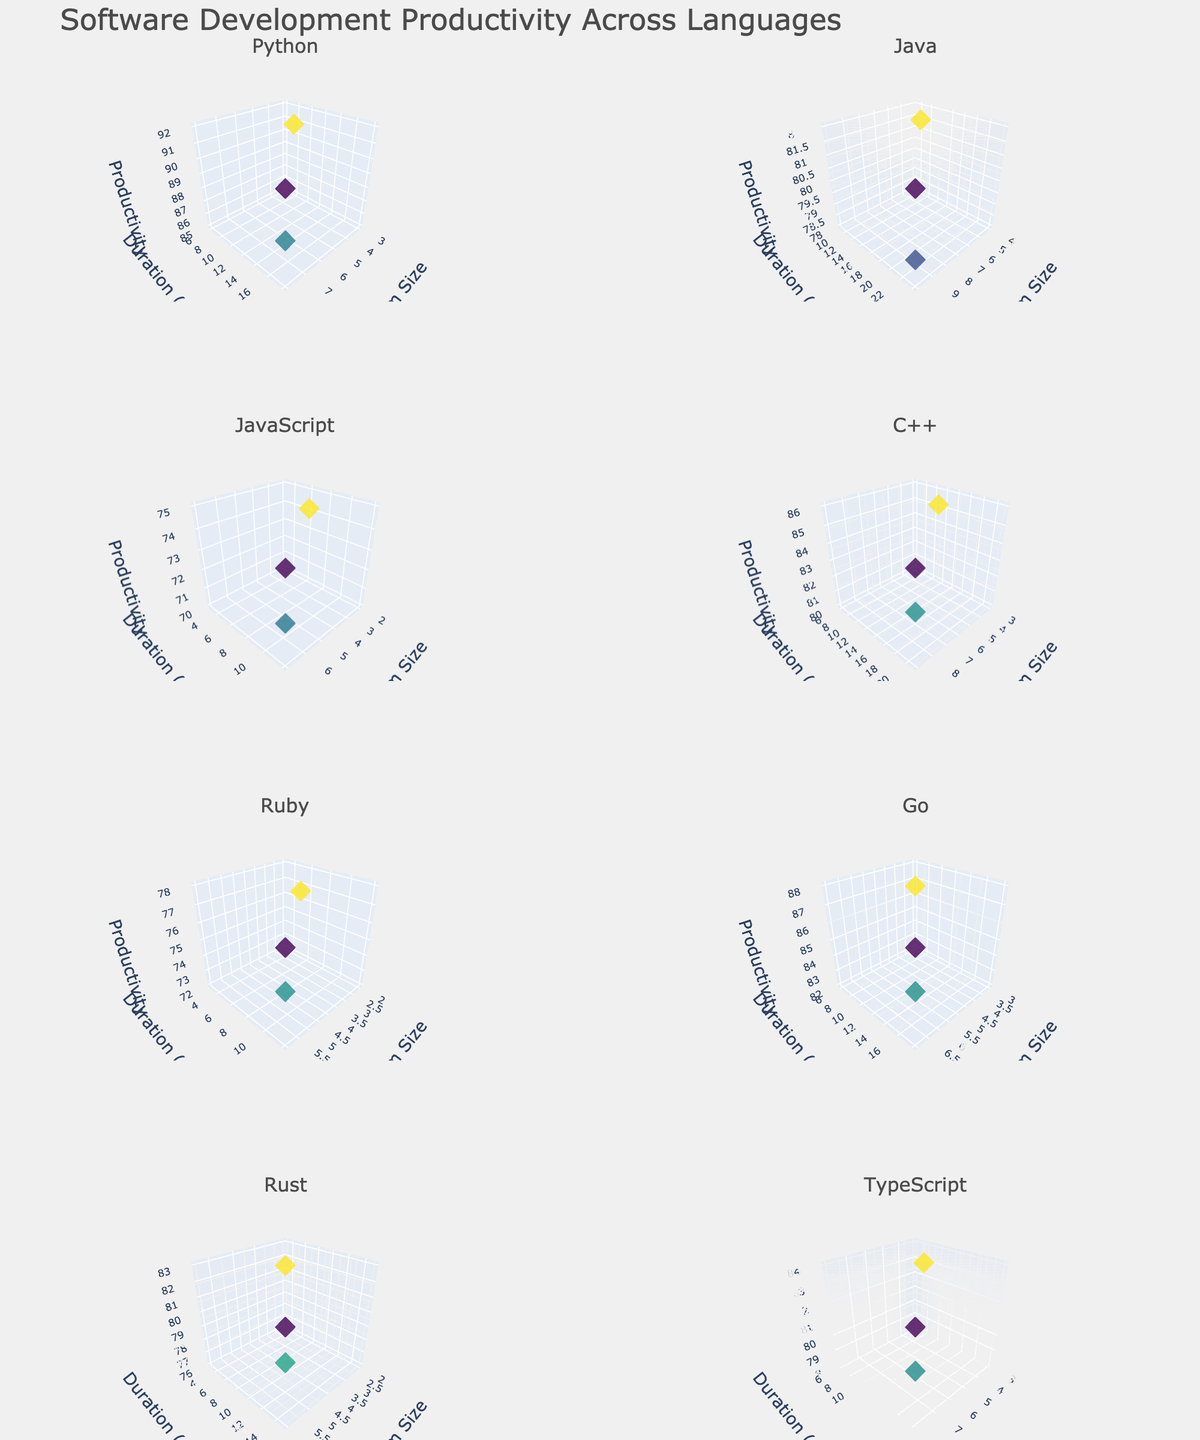How many subplots are there in the figure? There are 12 unique programming languages in the data. Each language is represented in a separate subplot, and the layout is arranged in 6 rows and 2 columns, resulting in a total of 12 subplots.
Answer: 12 Which language has the subplot with the highest maximum productivity? By examining the subplots, we see that the Python subplot has a data point with a productivity of 92, which is higher than the maximum values in the other subplots.
Answer: Python What is the average productivity across all programming languages for team size of 5? Looking at each subplot, we can extract the productivity values for team size 5: Python (92), Java (82), C++ (86), Go (88), TypeScript (84). The average is calculated as (92 + 82 + 86 + 88 + 84) / 5 = 86.4.
Answer: 86.4 How does productivity change with team size for Java? In the Java subplot, productivity values are 78 for team size 4, 82 for team size 6, and 79 for team size 10, suggesting a non-linear relationship with productivity peaking at a mid-sized team.
Answer: Peaks at mid-size Which language's productivity is least affected by project duration? By examining each subplot, we see the JavaScript subplot has smaller changes in productivity values (70 to 75), suggesting it is the least affected by project duration.
Answer: JavaScript Which programming language sees the highest productivity for short-duration (3 months) projects? For short-duration projects (3 months), Ruby has a productivity of 72, Rust has 76, JavaScript has 70. Rust has the highest productivity for short-duration projects.
Answer: Rust Among the programming languages, which one shows the biggest drop in productivity as team size increases? By examining the slope of the productivity trend with increasing team size, Java shows a noticeable drop from 82 at team size 6 to 79 at team size 10.
Answer: Java Do larger teams always lead to higher productivity in software development? Observing the subplots, we see that larger team sizes do not always lead to higher productivity. For instance, productivity decreases in cases like Java and C++.
Answer: No What is the relationship between team size and productivity for Go language projects? In the Go subplot, productivity values are 82 for team size 3, 88 for team size 5, and 85 for team size 7, indicating productivity initially increases with team size but then slightly decreases.
Answer: Increasing then decreasing 